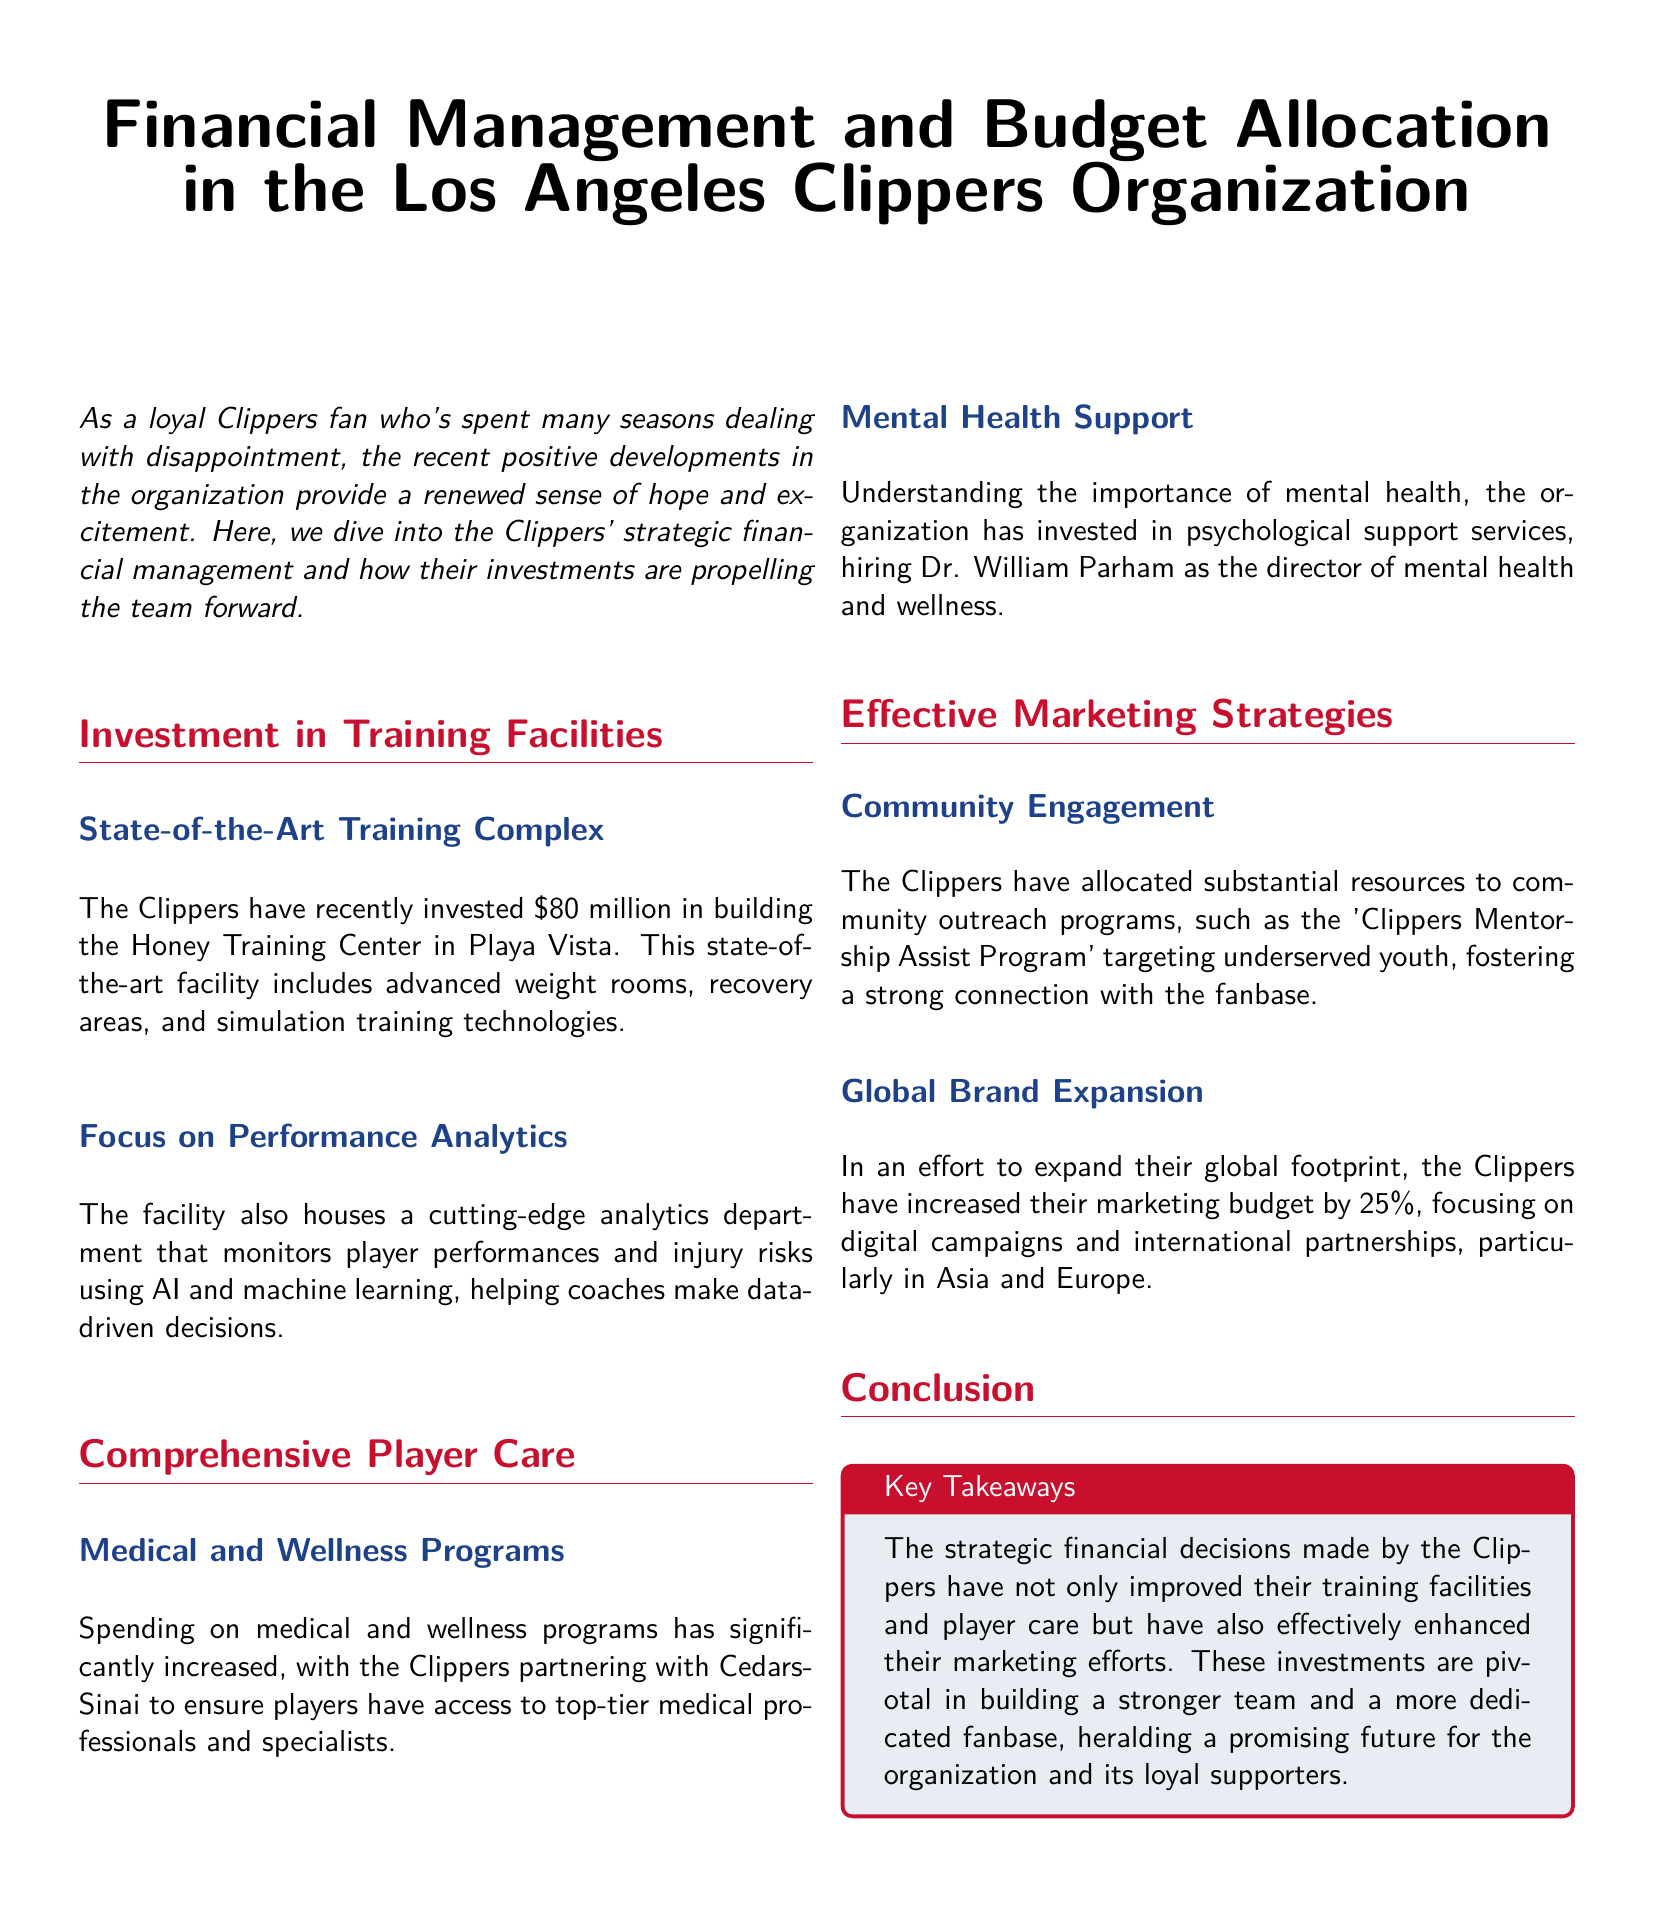What is the investment amount in the Honey Training Center? The investment amount for the Honey Training Center is stated as $80 million in the document.
Answer: $80 million What partnership is highlighted for player medical programs? The document mentions a partnership with Cedars-Sinai for player medical programs.
Answer: Cedars-Sinai Who has been hired as the director of mental health and wellness? The document identifies Dr. William Parham as the director of mental health and wellness.
Answer: Dr. William Parham By what percentage has the Clippers increased their marketing budget? According to the document, the Clippers have increased their marketing budget by 25 percent.
Answer: 25 percent What is the name of the community outreach program mentioned? The document refers to the 'Clippers Mentorship Assist Program' focusing on community engagement.
Answer: Clippers Mentorship Assist Program How does the Honey Training Center aid coaching decisions? The Honey Training Center aids coaching decisions through the use of AI and machine learning for performance analytics.
Answer: AI and machine learning Why are community outreach programs important for the Clippers? Community outreach programs are important for strengthening the connection with the fanbase, as highlighted in the document.
Answer: Strengthening connection with the fanbase What type of analytics does the new training complex focus on? The new training complex focuses on performance analytics, as mentioned in the document.
Answer: Performance analytics 